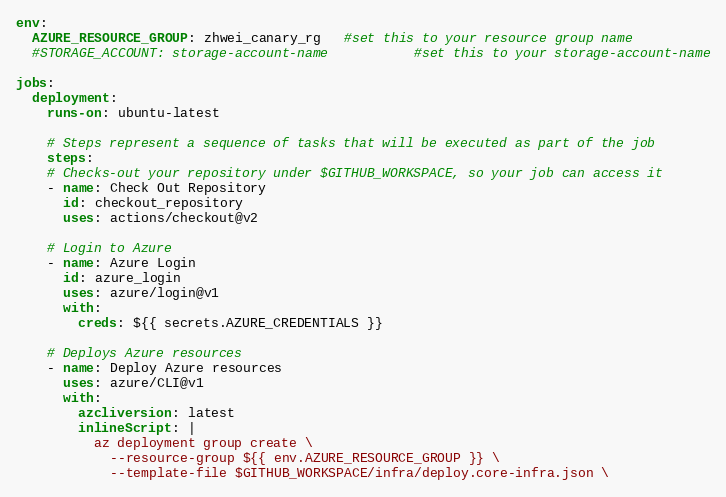<code> <loc_0><loc_0><loc_500><loc_500><_YAML_>env:
  AZURE_RESOURCE_GROUP: zhwei_canary_rg   #set this to your resource group name 
  #STORAGE_ACCOUNT: storage-account-name           #set this to your storage-account-name
    
jobs:
  deployment:
    runs-on: ubuntu-latest

    # Steps represent a sequence of tasks that will be executed as part of the job
    steps:
    # Checks-out your repository under $GITHUB_WORKSPACE, so your job can access it
    - name: Check Out Repository
      id: checkout_repository
      uses: actions/checkout@v2
    
    # Login to Azure
    - name: Azure Login
      id: azure_login
      uses: azure/login@v1
      with:
        creds: ${{ secrets.AZURE_CREDENTIALS }}
    
    # Deploys Azure resources 
    - name: Deploy Azure resources
      uses: azure/CLI@v1
      with:
        azcliversion: latest
        inlineScript: |
          az deployment group create \
            --resource-group ${{ env.AZURE_RESOURCE_GROUP }} \
            --template-file $GITHUB_WORKSPACE/infra/deploy.core-infra.json \</code> 